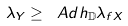Convert formula to latex. <formula><loc_0><loc_0><loc_500><loc_500>\lambda _ { Y } \geq \ A d h _ { \mathbb { D } } \lambda _ { f X }</formula> 